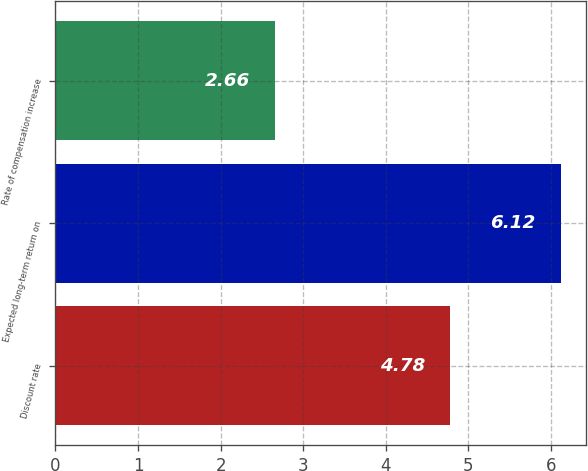Convert chart. <chart><loc_0><loc_0><loc_500><loc_500><bar_chart><fcel>Discount rate<fcel>Expected long-term return on<fcel>Rate of compensation increase<nl><fcel>4.78<fcel>6.12<fcel>2.66<nl></chart> 